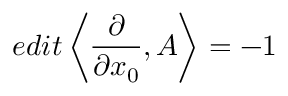Convert formula to latex. <formula><loc_0><loc_0><loc_500><loc_500>e d i t \left < \frac { \partial } { \partial x _ { 0 } } , A \right > = - 1</formula> 